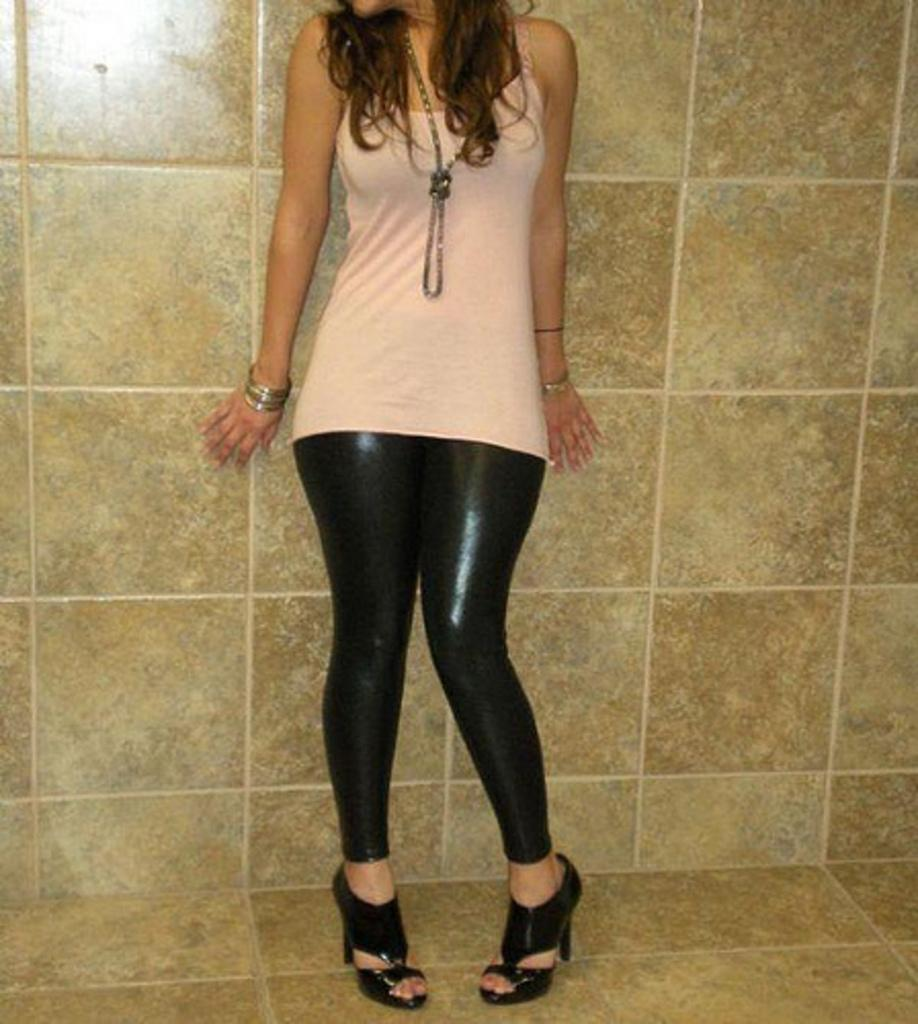Who is present in the image? There is a woman in the image. What is the woman's position in the image? The woman is standing on the floor. What can be seen in the background of the image? There is a wall in the image. What type of location might the image be taken in? The image is likely taken in a room. How does the woman use the brake in the image? There is no brake present in the image, as it is a woman standing in a room. 